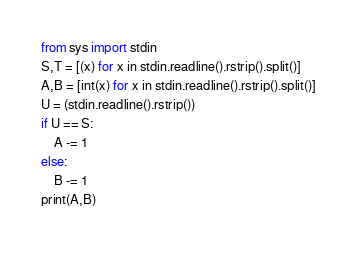<code> <loc_0><loc_0><loc_500><loc_500><_Python_>from sys import stdin
S,T = [(x) for x in stdin.readline().rstrip().split()]
A,B = [int(x) for x in stdin.readline().rstrip().split()]
U = (stdin.readline().rstrip())
if U == S:
    A -= 1
else:
    B -= 1
print(A,B)</code> 